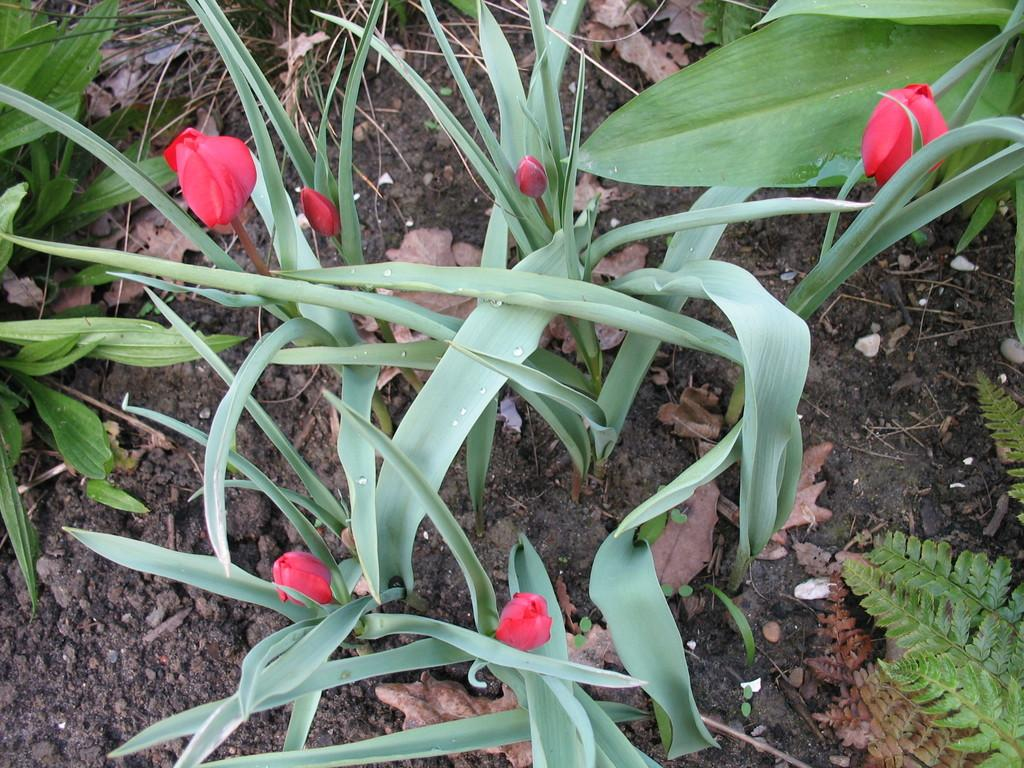What type of vegetation can be seen in the image? There are plants and flowers in the image. What is the condition of the soil in the image? There is mud in the image. What type of plant debris can be seen in the image? Dry leaves are present in the image. What part of the plants can be seen in the image? Leaves are visible in the image. What language is being spoken by the bird in the image? There is no bird present in the image, so it is not possible to determine what language might be spoken. 